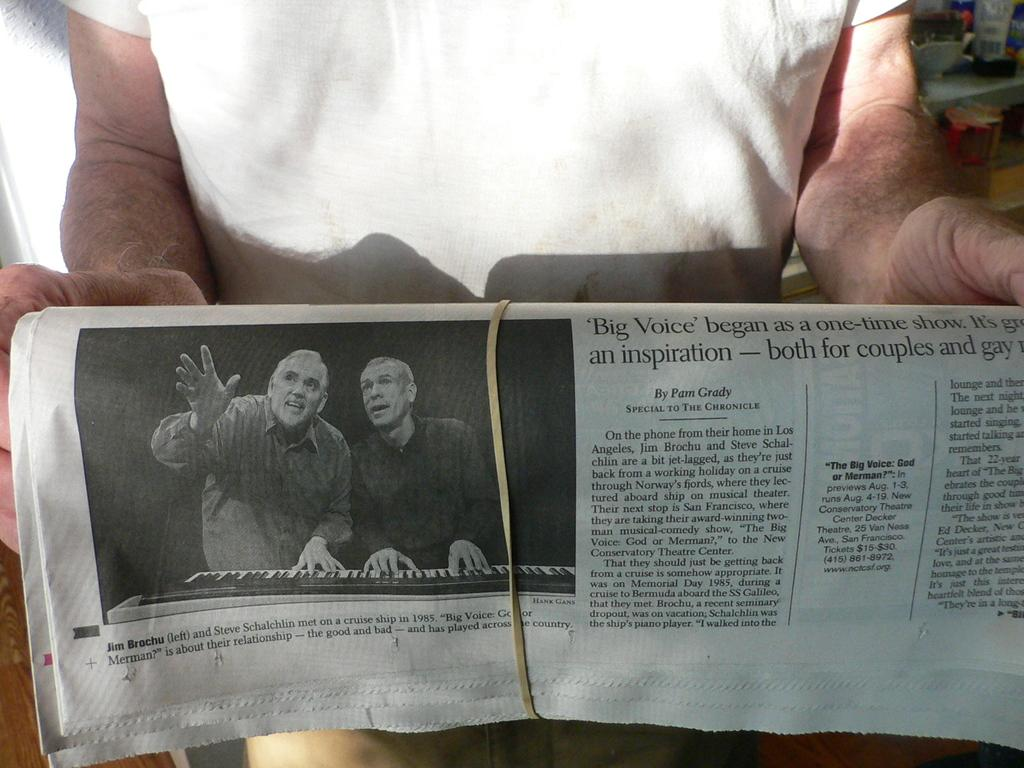Provide a one-sentence caption for the provided image. A person is holding a newspaper that is wrapped up with a rubber band and the head line Big Voice showing. 